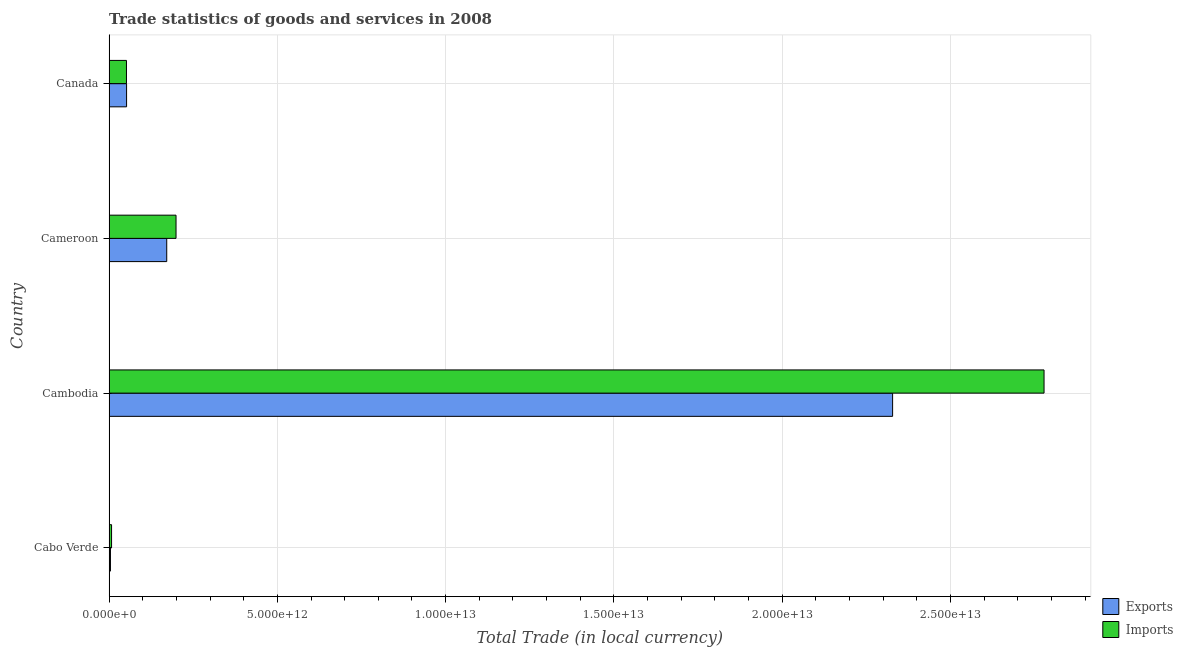Are the number of bars per tick equal to the number of legend labels?
Keep it short and to the point. Yes. How many bars are there on the 2nd tick from the bottom?
Offer a very short reply. 2. What is the label of the 3rd group of bars from the top?
Provide a short and direct response. Cambodia. What is the export of goods and services in Cambodia?
Ensure brevity in your answer.  2.33e+13. Across all countries, what is the maximum export of goods and services?
Provide a succinct answer. 2.33e+13. Across all countries, what is the minimum export of goods and services?
Your answer should be very brief. 4.13e+1. In which country was the imports of goods and services maximum?
Make the answer very short. Cambodia. In which country was the export of goods and services minimum?
Your answer should be very brief. Cabo Verde. What is the total export of goods and services in the graph?
Your response must be concise. 2.56e+13. What is the difference between the imports of goods and services in Cabo Verde and that in Cameroon?
Make the answer very short. -1.92e+12. What is the difference between the export of goods and services in Canada and the imports of goods and services in Cabo Verde?
Make the answer very short. 4.46e+11. What is the average imports of goods and services per country?
Your answer should be compact. 7.59e+12. What is the difference between the export of goods and services and imports of goods and services in Cabo Verde?
Your answer should be compact. -3.31e+1. In how many countries, is the imports of goods and services greater than 3000000000000 LCU?
Make the answer very short. 1. What is the ratio of the export of goods and services in Cambodia to that in Cameroon?
Offer a very short reply. 13.59. Is the export of goods and services in Cabo Verde less than that in Canada?
Your answer should be very brief. Yes. Is the difference between the imports of goods and services in Cabo Verde and Cameroon greater than the difference between the export of goods and services in Cabo Verde and Cameroon?
Provide a succinct answer. No. What is the difference between the highest and the second highest imports of goods and services?
Ensure brevity in your answer.  2.58e+13. What is the difference between the highest and the lowest export of goods and services?
Your response must be concise. 2.32e+13. In how many countries, is the export of goods and services greater than the average export of goods and services taken over all countries?
Give a very brief answer. 1. Is the sum of the export of goods and services in Cabo Verde and Cambodia greater than the maximum imports of goods and services across all countries?
Give a very brief answer. No. What does the 1st bar from the top in Canada represents?
Give a very brief answer. Imports. What does the 2nd bar from the bottom in Cabo Verde represents?
Your answer should be very brief. Imports. Are all the bars in the graph horizontal?
Make the answer very short. Yes. How many countries are there in the graph?
Your response must be concise. 4. What is the difference between two consecutive major ticks on the X-axis?
Your answer should be very brief. 5.00e+12. Does the graph contain grids?
Your answer should be very brief. Yes. Where does the legend appear in the graph?
Your answer should be compact. Bottom right. How many legend labels are there?
Make the answer very short. 2. What is the title of the graph?
Make the answer very short. Trade statistics of goods and services in 2008. Does "Long-term debt" appear as one of the legend labels in the graph?
Provide a short and direct response. No. What is the label or title of the X-axis?
Provide a short and direct response. Total Trade (in local currency). What is the label or title of the Y-axis?
Keep it short and to the point. Country. What is the Total Trade (in local currency) of Exports in Cabo Verde?
Give a very brief answer. 4.13e+1. What is the Total Trade (in local currency) in Imports in Cabo Verde?
Provide a short and direct response. 7.44e+1. What is the Total Trade (in local currency) in Exports in Cambodia?
Provide a short and direct response. 2.33e+13. What is the Total Trade (in local currency) in Imports in Cambodia?
Provide a short and direct response. 2.78e+13. What is the Total Trade (in local currency) in Exports in Cameroon?
Keep it short and to the point. 1.71e+12. What is the Total Trade (in local currency) of Imports in Cameroon?
Ensure brevity in your answer.  1.99e+12. What is the Total Trade (in local currency) of Exports in Canada?
Ensure brevity in your answer.  5.20e+11. What is the Total Trade (in local currency) of Imports in Canada?
Your answer should be compact. 5.17e+11. Across all countries, what is the maximum Total Trade (in local currency) of Exports?
Your answer should be very brief. 2.33e+13. Across all countries, what is the maximum Total Trade (in local currency) of Imports?
Offer a terse response. 2.78e+13. Across all countries, what is the minimum Total Trade (in local currency) in Exports?
Provide a succinct answer. 4.13e+1. Across all countries, what is the minimum Total Trade (in local currency) of Imports?
Provide a short and direct response. 7.44e+1. What is the total Total Trade (in local currency) in Exports in the graph?
Make the answer very short. 2.56e+13. What is the total Total Trade (in local currency) in Imports in the graph?
Make the answer very short. 3.04e+13. What is the difference between the Total Trade (in local currency) in Exports in Cabo Verde and that in Cambodia?
Provide a succinct answer. -2.32e+13. What is the difference between the Total Trade (in local currency) of Imports in Cabo Verde and that in Cambodia?
Offer a very short reply. -2.77e+13. What is the difference between the Total Trade (in local currency) of Exports in Cabo Verde and that in Cameroon?
Make the answer very short. -1.67e+12. What is the difference between the Total Trade (in local currency) in Imports in Cabo Verde and that in Cameroon?
Your answer should be very brief. -1.92e+12. What is the difference between the Total Trade (in local currency) of Exports in Cabo Verde and that in Canada?
Your answer should be compact. -4.79e+11. What is the difference between the Total Trade (in local currency) of Imports in Cabo Verde and that in Canada?
Your response must be concise. -4.43e+11. What is the difference between the Total Trade (in local currency) in Exports in Cambodia and that in Cameroon?
Make the answer very short. 2.16e+13. What is the difference between the Total Trade (in local currency) of Imports in Cambodia and that in Cameroon?
Your answer should be very brief. 2.58e+13. What is the difference between the Total Trade (in local currency) of Exports in Cambodia and that in Canada?
Ensure brevity in your answer.  2.28e+13. What is the difference between the Total Trade (in local currency) in Imports in Cambodia and that in Canada?
Your answer should be compact. 2.73e+13. What is the difference between the Total Trade (in local currency) of Exports in Cameroon and that in Canada?
Offer a terse response. 1.19e+12. What is the difference between the Total Trade (in local currency) of Imports in Cameroon and that in Canada?
Provide a short and direct response. 1.47e+12. What is the difference between the Total Trade (in local currency) of Exports in Cabo Verde and the Total Trade (in local currency) of Imports in Cambodia?
Keep it short and to the point. -2.77e+13. What is the difference between the Total Trade (in local currency) of Exports in Cabo Verde and the Total Trade (in local currency) of Imports in Cameroon?
Ensure brevity in your answer.  -1.95e+12. What is the difference between the Total Trade (in local currency) in Exports in Cabo Verde and the Total Trade (in local currency) in Imports in Canada?
Keep it short and to the point. -4.76e+11. What is the difference between the Total Trade (in local currency) in Exports in Cambodia and the Total Trade (in local currency) in Imports in Cameroon?
Your response must be concise. 2.13e+13. What is the difference between the Total Trade (in local currency) in Exports in Cambodia and the Total Trade (in local currency) in Imports in Canada?
Keep it short and to the point. 2.28e+13. What is the difference between the Total Trade (in local currency) of Exports in Cameroon and the Total Trade (in local currency) of Imports in Canada?
Provide a succinct answer. 1.20e+12. What is the average Total Trade (in local currency) in Exports per country?
Make the answer very short. 6.39e+12. What is the average Total Trade (in local currency) of Imports per country?
Ensure brevity in your answer.  7.59e+12. What is the difference between the Total Trade (in local currency) in Exports and Total Trade (in local currency) in Imports in Cabo Verde?
Give a very brief answer. -3.31e+1. What is the difference between the Total Trade (in local currency) of Exports and Total Trade (in local currency) of Imports in Cambodia?
Give a very brief answer. -4.50e+12. What is the difference between the Total Trade (in local currency) in Exports and Total Trade (in local currency) in Imports in Cameroon?
Your response must be concise. -2.76e+11. What is the difference between the Total Trade (in local currency) of Exports and Total Trade (in local currency) of Imports in Canada?
Make the answer very short. 3.17e+09. What is the ratio of the Total Trade (in local currency) in Exports in Cabo Verde to that in Cambodia?
Your response must be concise. 0. What is the ratio of the Total Trade (in local currency) of Imports in Cabo Verde to that in Cambodia?
Keep it short and to the point. 0. What is the ratio of the Total Trade (in local currency) in Exports in Cabo Verde to that in Cameroon?
Give a very brief answer. 0.02. What is the ratio of the Total Trade (in local currency) in Imports in Cabo Verde to that in Cameroon?
Your response must be concise. 0.04. What is the ratio of the Total Trade (in local currency) in Exports in Cabo Verde to that in Canada?
Your answer should be compact. 0.08. What is the ratio of the Total Trade (in local currency) in Imports in Cabo Verde to that in Canada?
Offer a very short reply. 0.14. What is the ratio of the Total Trade (in local currency) of Exports in Cambodia to that in Cameroon?
Your answer should be very brief. 13.59. What is the ratio of the Total Trade (in local currency) in Imports in Cambodia to that in Cameroon?
Give a very brief answer. 13.96. What is the ratio of the Total Trade (in local currency) of Exports in Cambodia to that in Canada?
Your answer should be very brief. 44.75. What is the ratio of the Total Trade (in local currency) of Imports in Cambodia to that in Canada?
Provide a succinct answer. 53.73. What is the ratio of the Total Trade (in local currency) of Exports in Cameroon to that in Canada?
Provide a succinct answer. 3.29. What is the ratio of the Total Trade (in local currency) in Imports in Cameroon to that in Canada?
Offer a terse response. 3.85. What is the difference between the highest and the second highest Total Trade (in local currency) in Exports?
Give a very brief answer. 2.16e+13. What is the difference between the highest and the second highest Total Trade (in local currency) of Imports?
Provide a short and direct response. 2.58e+13. What is the difference between the highest and the lowest Total Trade (in local currency) in Exports?
Provide a succinct answer. 2.32e+13. What is the difference between the highest and the lowest Total Trade (in local currency) of Imports?
Your answer should be very brief. 2.77e+13. 